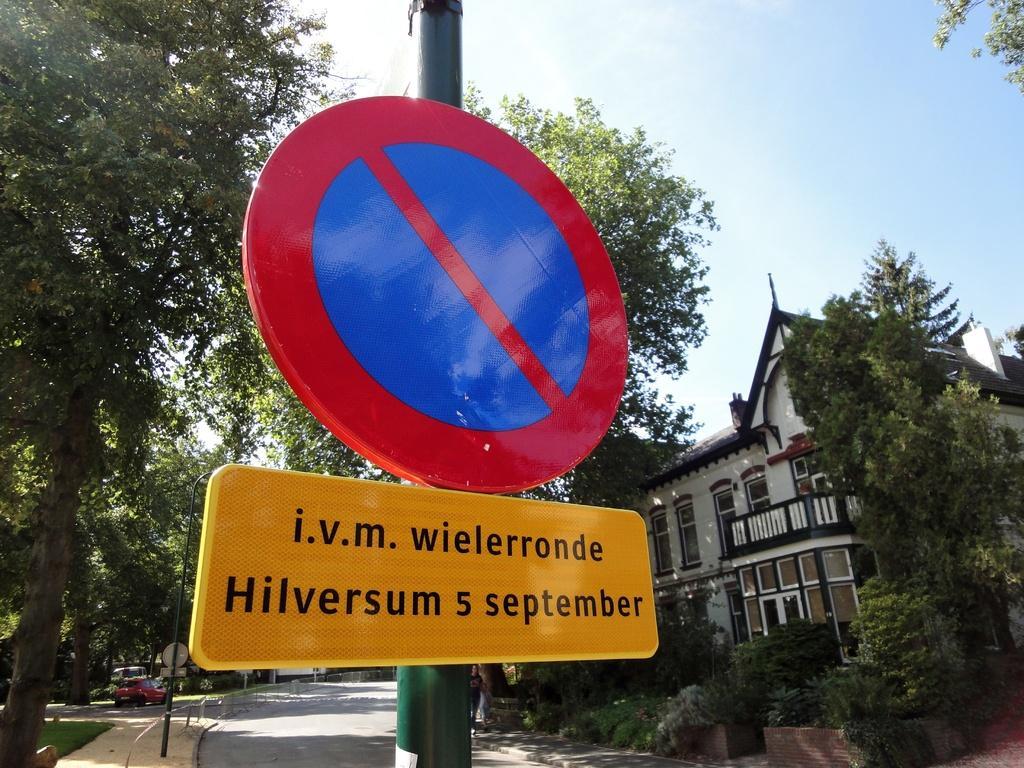Describe this image in one or two sentences. This picture is clicked outside. In the foreground we can see the boards attached to the pole and the text is written on the board. On the right there is a building and we can see the trees, plants and the road. On the left there are some vehicles seems to be parked on the ground. In the background there is a sky and the trees. 